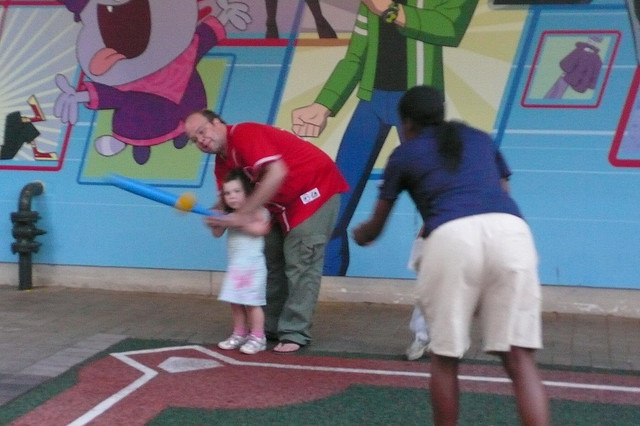Describe the objects in this image and their specific colors. I can see people in brown, lightgray, black, darkgray, and navy tones, people in brown, gray, and maroon tones, people in brown, darkgray, gray, and lightblue tones, baseball bat in brown, gray, and lightblue tones, and sports ball in brown, tan, olive, and darkgray tones in this image. 